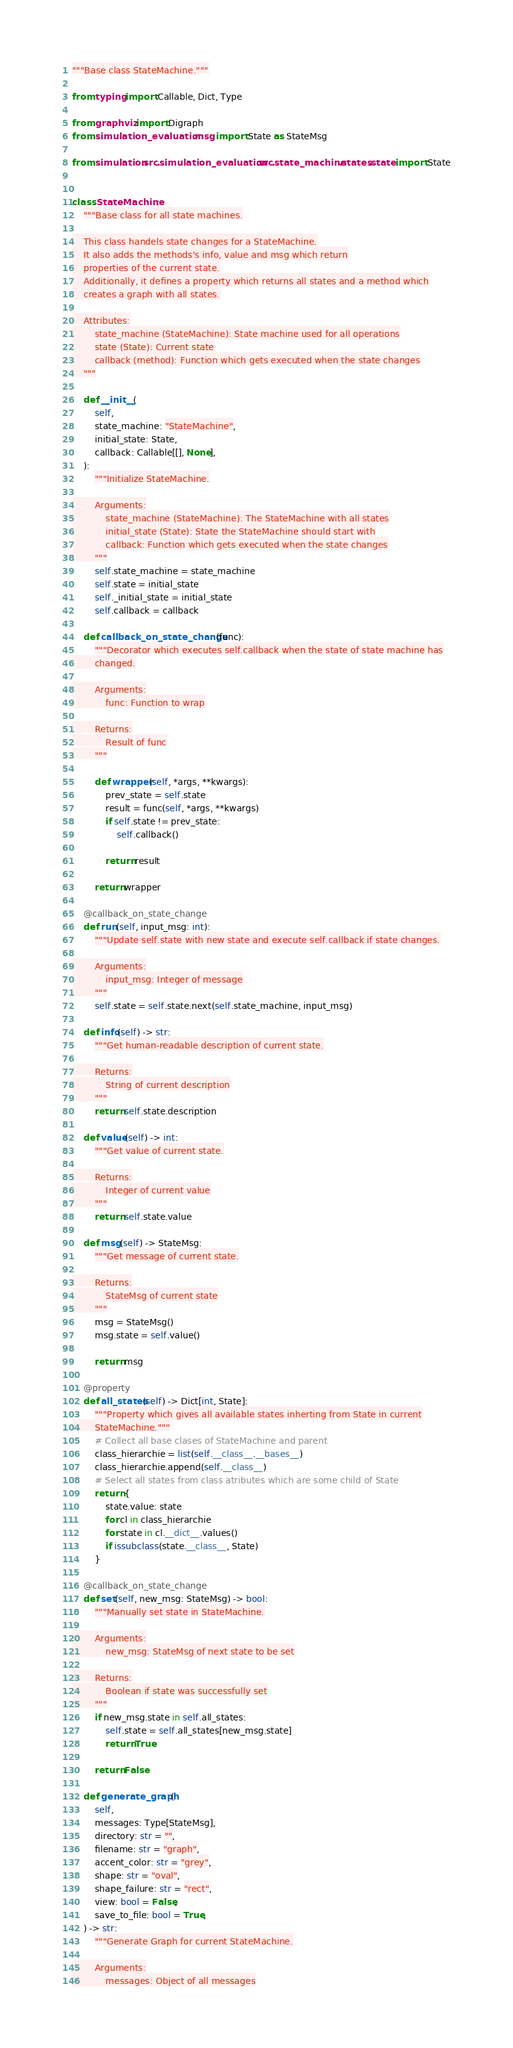<code> <loc_0><loc_0><loc_500><loc_500><_Python_>"""Base class StateMachine."""

from typing import Callable, Dict, Type

from graphviz import Digraph
from simulation_evaluation.msg import State as StateMsg

from simulation.src.simulation_evaluation.src.state_machine.states.state import State


class StateMachine:
    """Base class for all state machines.

    This class handels state changes for a StateMachine.
    It also adds the methods's info, value and msg which return
    properties of the current state.
    Additionally, it defines a property which returns all states and a method which
    creates a graph with all states.

    Attributes:
        state_machine (StateMachine): State machine used for all operations
        state (State): Current state
        callback (method): Function which gets executed when the state changes
    """

    def __init__(
        self,
        state_machine: "StateMachine",
        initial_state: State,
        callback: Callable[[], None],
    ):
        """Initialize StateMachine.

        Arguments:
            state_machine (StateMachine): The StateMachine with all states
            initial_state (State): State the StateMachine should start with
            callback: Function which gets executed when the state changes
        """
        self.state_machine = state_machine
        self.state = initial_state
        self._initial_state = initial_state
        self.callback = callback

    def callback_on_state_change(func):
        """Decorator which executes self.callback when the state of state machine has
        changed.

        Arguments:
            func: Function to wrap

        Returns:
            Result of func
        """

        def wrapper(self, *args, **kwargs):
            prev_state = self.state
            result = func(self, *args, **kwargs)
            if self.state != prev_state:
                self.callback()

            return result

        return wrapper

    @callback_on_state_change
    def run(self, input_msg: int):
        """Update self.state with new state and execute self.callback if state changes.

        Arguments:
            input_msg: Integer of message
        """
        self.state = self.state.next(self.state_machine, input_msg)

    def info(self) -> str:
        """Get human-readable description of current state.

        Returns:
            String of current description
        """
        return self.state.description

    def value(self) -> int:
        """Get value of current state.

        Returns:
            Integer of current value
        """
        return self.state.value

    def msg(self) -> StateMsg:
        """Get message of current state.

        Returns:
            StateMsg of current state
        """
        msg = StateMsg()
        msg.state = self.value()

        return msg

    @property
    def all_states(self) -> Dict[int, State]:
        """Property which gives all available states inherting from State in current
        StateMachine."""
        # Collect all base clases of StateMachine and parent
        class_hierarchie = list(self.__class__.__bases__)
        class_hierarchie.append(self.__class__)
        # Select all states from class atributes which are some child of State
        return {
            state.value: state
            for cl in class_hierarchie
            for state in cl.__dict__.values()
            if issubclass(state.__class__, State)
        }

    @callback_on_state_change
    def set(self, new_msg: StateMsg) -> bool:
        """Manually set state in StateMachine.

        Arguments:
            new_msg: StateMsg of next state to be set

        Returns:
            Boolean if state was successfully set
        """
        if new_msg.state in self.all_states:
            self.state = self.all_states[new_msg.state]
            return True

        return False

    def generate_graph(
        self,
        messages: Type[StateMsg],
        directory: str = "",
        filename: str = "graph",
        accent_color: str = "grey",
        shape: str = "oval",
        shape_failure: str = "rect",
        view: bool = False,
        save_to_file: bool = True,
    ) -> str:
        """Generate Graph for current StateMachine.

        Arguments:
            messages: Object of all messages</code> 